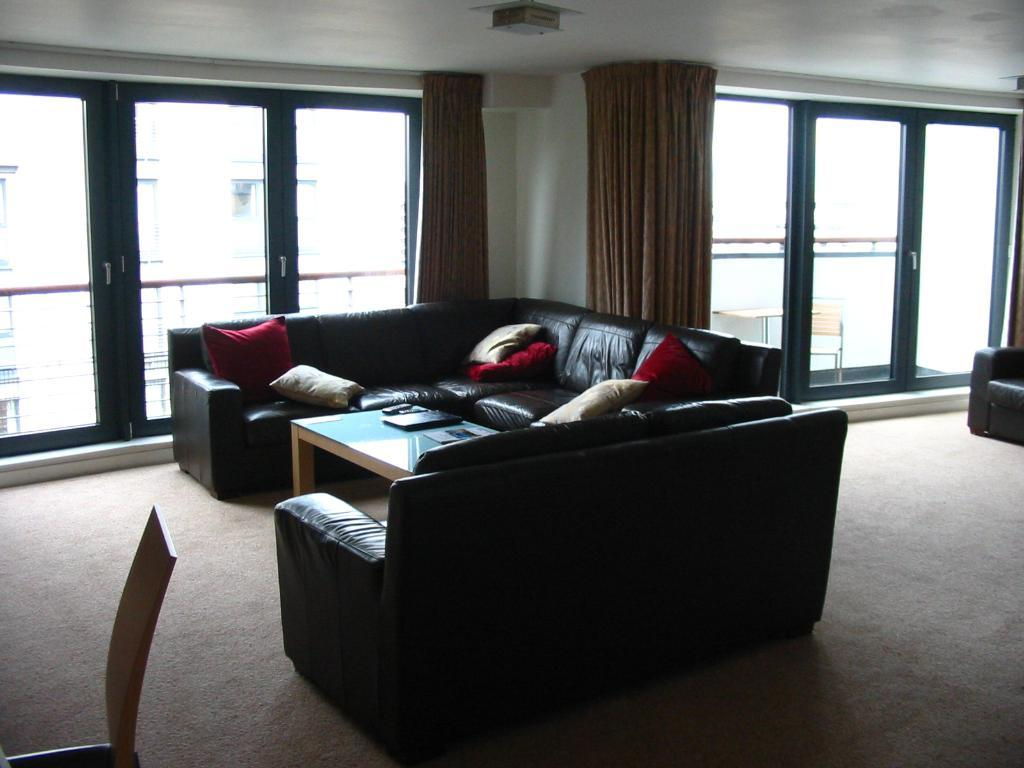What type of furniture is in the room with pillows? There is a sofa with pillows in the room. What is located in front of the sofa? There is a table in front of the sofa. What electronic device is on the table? A laptop is present on the table. What can be seen in the background of the room? There is a door in the background of the room. What type of window treatment is associated with the door? Curtains are associated with the door. What type of baseball is visible on the sofa? There is no baseball present in the image; it features a sofa with pillows, a table, a laptop, a door, and curtains. 